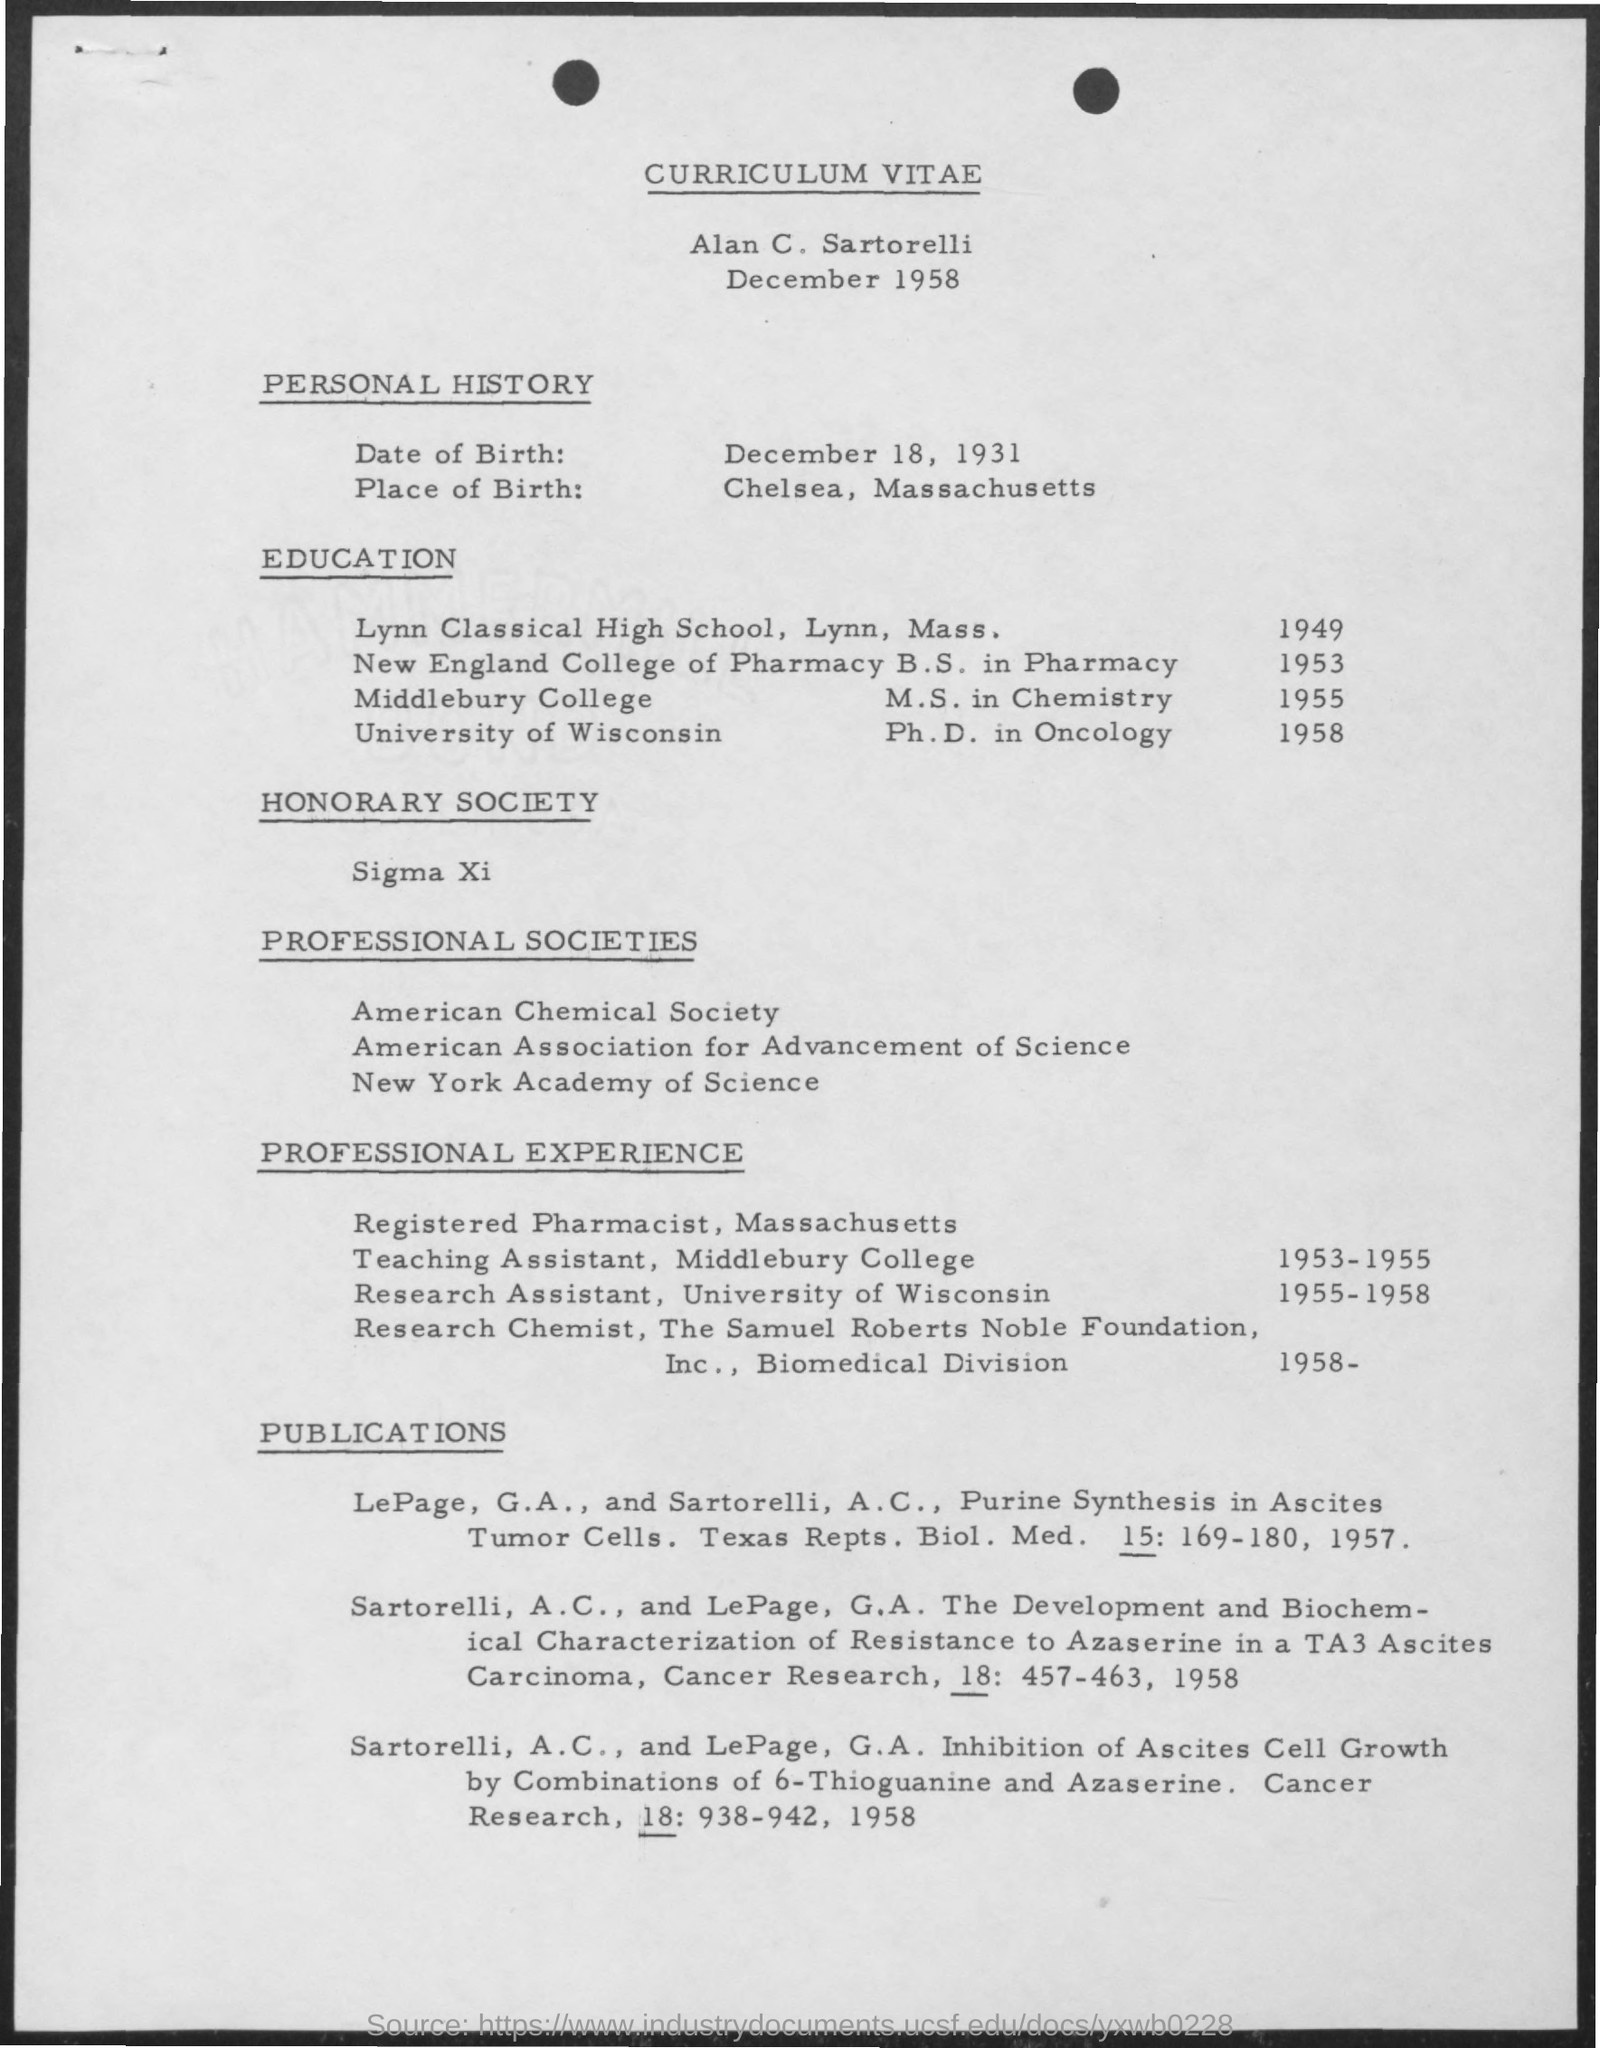Who's Curriculum Vitae is given here?
Offer a terse response. Alan C. Sartorelli. What is the Date of Birth of Alan C. Sartorelli?
Give a very brief answer. December 18, 1931. What is the Place of Birth of Alan C. Sartorelli?
Provide a succinct answer. CHELSEA, MASSACHUSETTS. When did Alan C. Sartorelli  completed M.S. in Chemistry from Middlebury College?
Make the answer very short. 1955. Where did Alan C. Sartorelli complete a Ph.D. in Oncology in 1958?
Your answer should be very brief. University of Wisconsin. During which period, Alan C. Sartorelli worked as a Research Assistant, University of Wisconsin?
Your answer should be very brief. 1955-1958. During which period, Alan C. Sartorelli worked as a Teaching Assistant, Middlebury College?
Provide a short and direct response. 1953-1955. In which college, Alan C. Sartorelli has done B.S. in Pharmacy?
Keep it short and to the point. New England College of Pharmacy. 